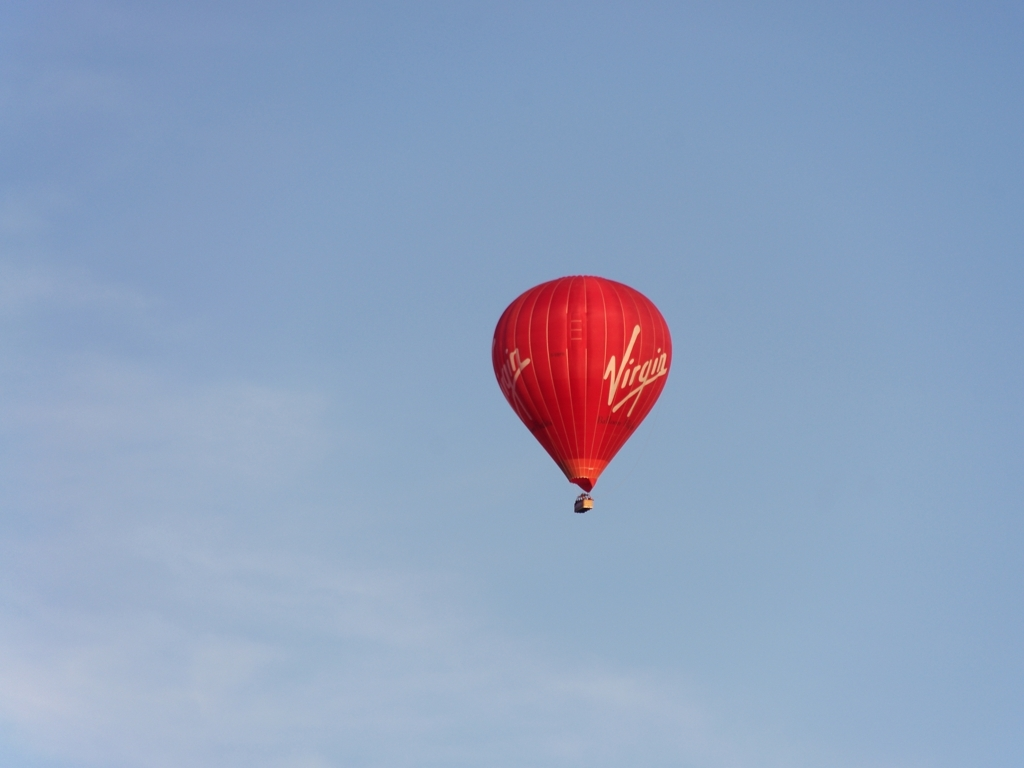What emotions might this image evoke? The image may evoke a sense of calmness and freedom due to the vast open sky and the gentle nature of hot air balloon flights. There's also a hint of adventure and exploration associated with ballooning. Is there any indication of the location or event? Without additional context, the specific location or event is not clear. However, the presence of the 'Virgin' brand may suggest a commercial or promotional flight. 